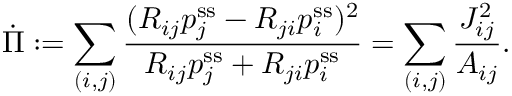<formula> <loc_0><loc_0><loc_500><loc_500>\dot { \Pi } \colon = \sum _ { ( i , j ) } \frac { ( R _ { i j } p _ { j } ^ { s s } - R _ { j i } p _ { i } ^ { s s } ) ^ { 2 } } { R _ { i j } p _ { j } ^ { s s } + R _ { j i } p _ { i } ^ { s s } } = \sum _ { ( i , j ) } \frac { J _ { i j } ^ { 2 } } { A _ { i j } } .</formula> 